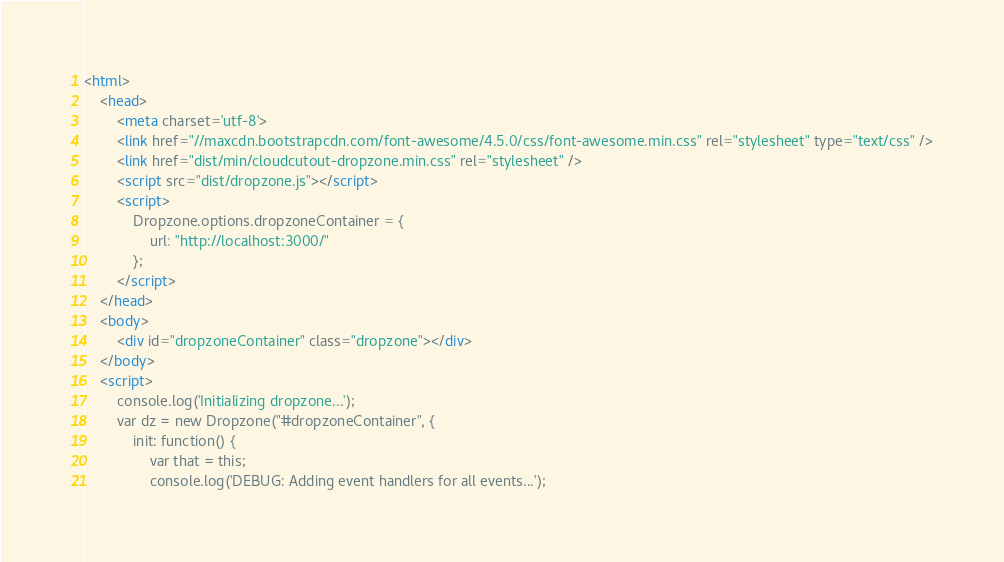<code> <loc_0><loc_0><loc_500><loc_500><_HTML_><html>
    <head>
        <meta charset='utf-8'>
        <link href="//maxcdn.bootstrapcdn.com/font-awesome/4.5.0/css/font-awesome.min.css" rel="stylesheet" type="text/css" />
        <link href="dist/min/cloudcutout-dropzone.min.css" rel="stylesheet" />
        <script src="dist/dropzone.js"></script>
        <script>
            Dropzone.options.dropzoneContainer = {
                url: "http://localhost:3000/"
            };
        </script>
    </head>
    <body>
        <div id="dropzoneContainer" class="dropzone"></div>
    </body>
    <script>
        console.log('Initializing dropzone...');
        var dz = new Dropzone("#dropzoneContainer", {
            init: function() {
                var that = this;
                console.log('DEBUG: Adding event handlers for all events...');</code> 